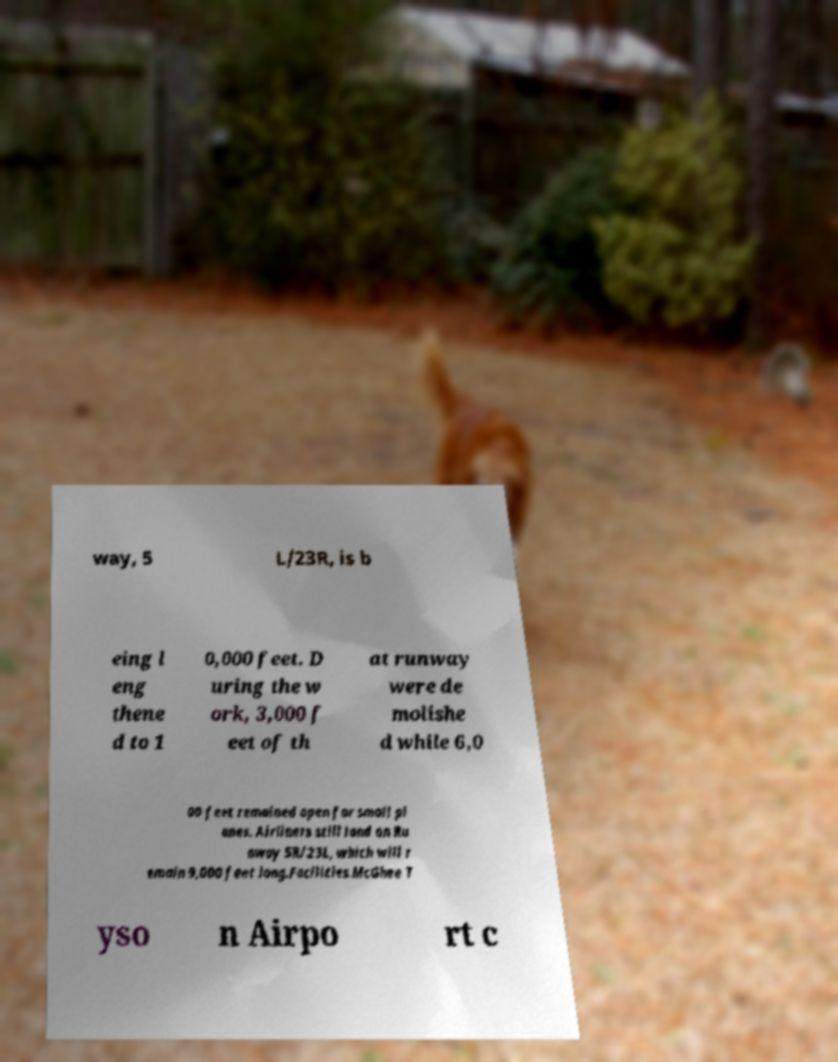For documentation purposes, I need the text within this image transcribed. Could you provide that? way, 5 L/23R, is b eing l eng thene d to 1 0,000 feet. D uring the w ork, 3,000 f eet of th at runway were de molishe d while 6,0 00 feet remained open for small pl anes. Airliners still land on Ru nway 5R/23L, which will r emain 9,000 feet long.Facilities.McGhee T yso n Airpo rt c 